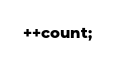Convert code to text. <code><loc_0><loc_0><loc_500><loc_500><_ObjectiveC_>++count;
</code> 